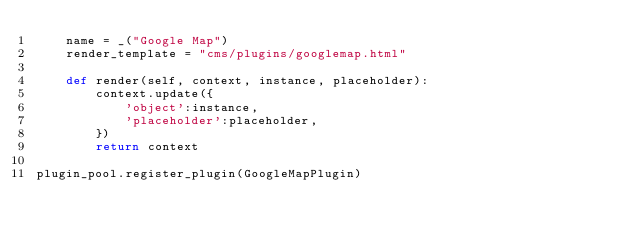Convert code to text. <code><loc_0><loc_0><loc_500><loc_500><_Python_>    name = _("Google Map")
    render_template = "cms/plugins/googlemap.html"
    
    def render(self, context, instance, placeholder):
        context.update({
            'object':instance, 
            'placeholder':placeholder, 
        })
        return context

plugin_pool.register_plugin(GoogleMapPlugin)</code> 